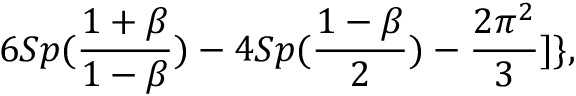Convert formula to latex. <formula><loc_0><loc_0><loc_500><loc_500>6 S p ( { \frac { 1 + \beta } { 1 - \beta } } ) - 4 S p ( { \frac { 1 - \beta } { 2 } } ) - { \frac { 2 \pi ^ { 2 } } { 3 } } ] \} ,</formula> 